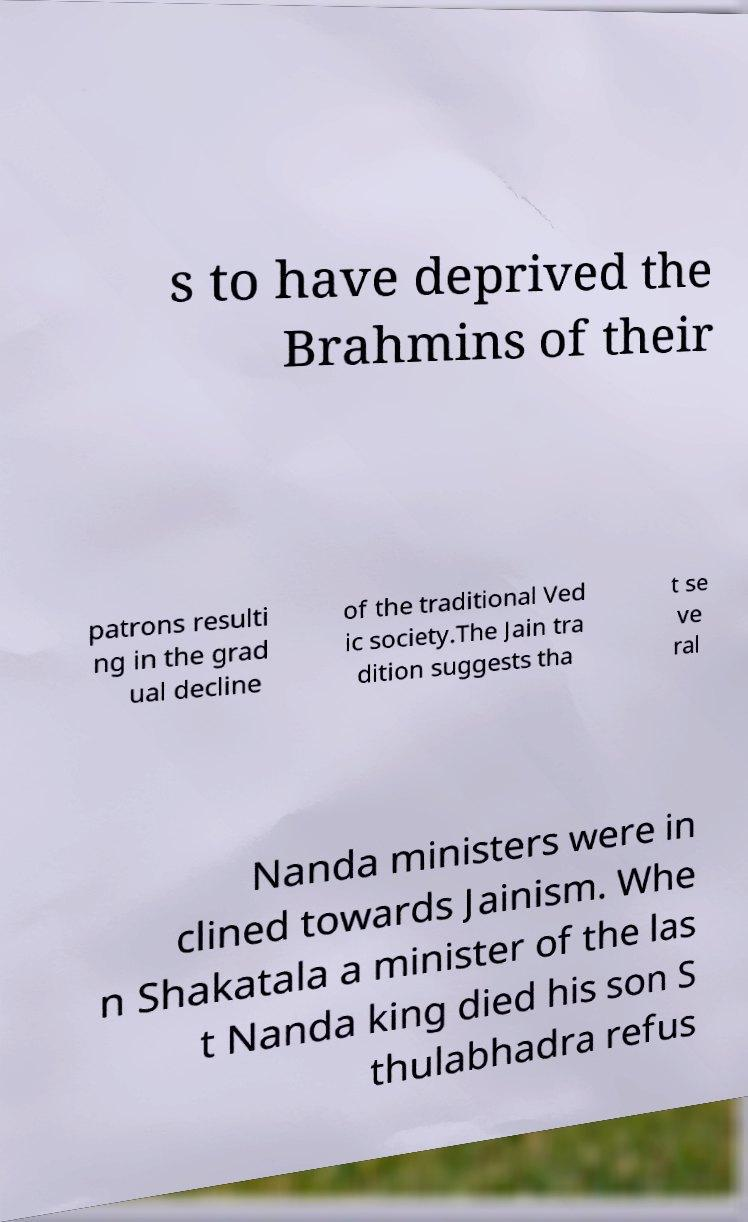Could you assist in decoding the text presented in this image and type it out clearly? s to have deprived the Brahmins of their patrons resulti ng in the grad ual decline of the traditional Ved ic society.The Jain tra dition suggests tha t se ve ral Nanda ministers were in clined towards Jainism. Whe n Shakatala a minister of the las t Nanda king died his son S thulabhadra refus 